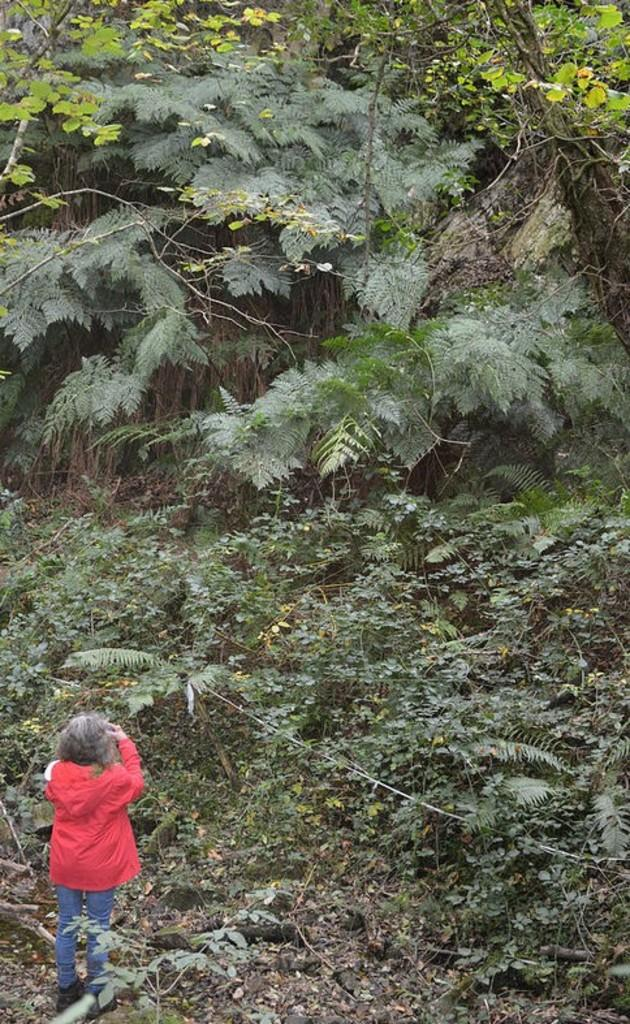What is present on the ground in the image? There are plants on the ground in the image. What else can be seen in the image? There is a girl standing in the image. What is the girl wearing? The girl is wearing a red color hoodie. Can you see a frog hopping around in the image? There is no frog present in the image. Is the girl moving or walking in the image? The image does not show the girl moving or walking; she is standing still. 